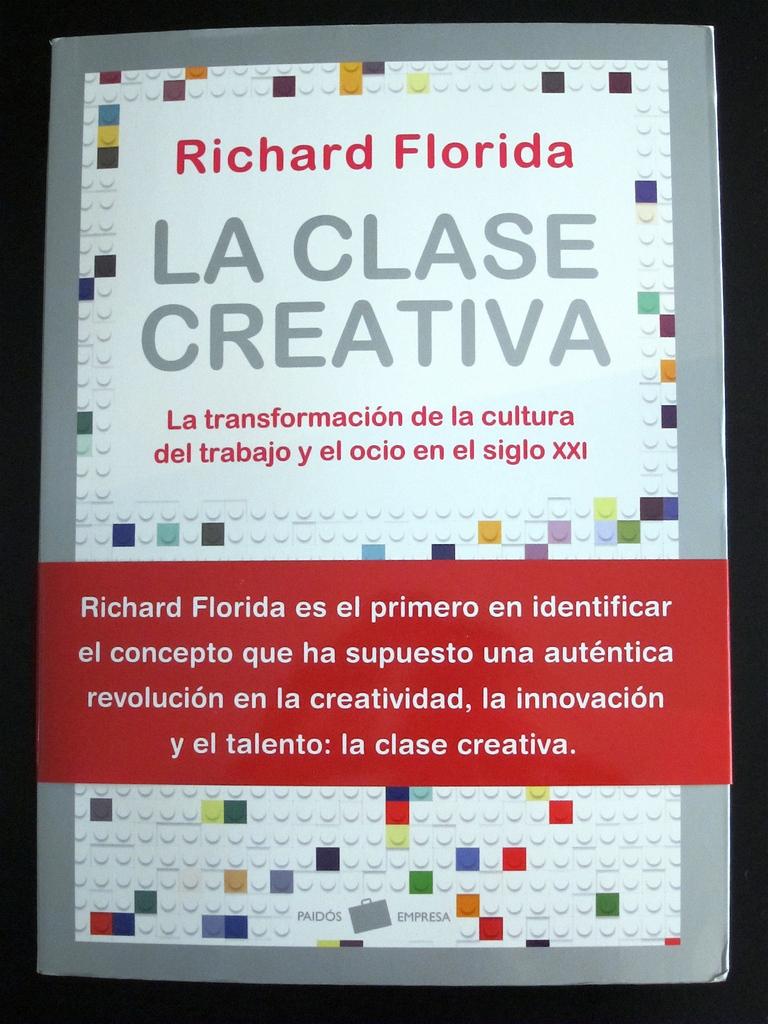Whose name is on the ad?
Provide a succinct answer. Richard florida. What is the title of the book?
Provide a short and direct response. La clase creativa. 